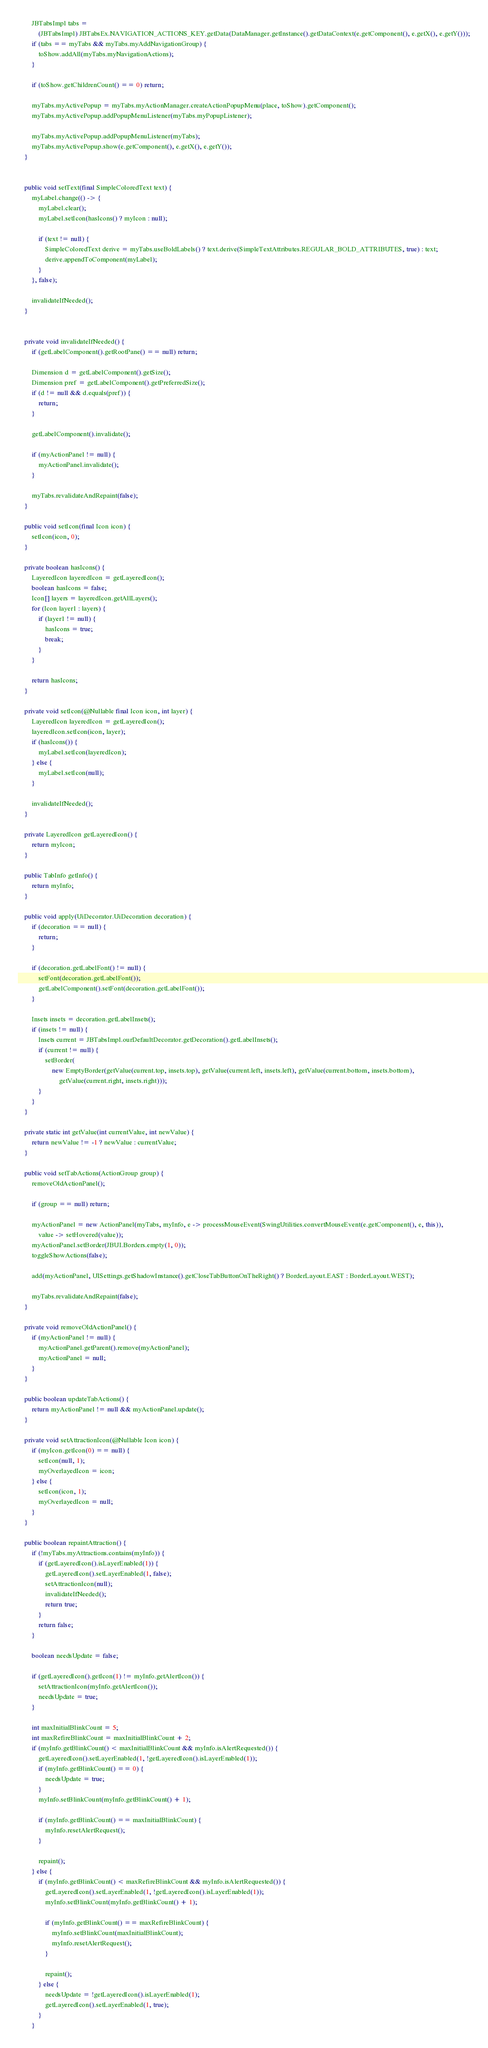Convert code to text. <code><loc_0><loc_0><loc_500><loc_500><_Java_>		JBTabsImpl tabs =
			(JBTabsImpl) JBTabsEx.NAVIGATION_ACTIONS_KEY.getData(DataManager.getInstance().getDataContext(e.getComponent(), e.getX(), e.getY()));
		if (tabs == myTabs && myTabs.myAddNavigationGroup) {
			toShow.addAll(myTabs.myNavigationActions);
		}

		if (toShow.getChildrenCount() == 0) return;

		myTabs.myActivePopup = myTabs.myActionManager.createActionPopupMenu(place, toShow).getComponent();
		myTabs.myActivePopup.addPopupMenuListener(myTabs.myPopupListener);

		myTabs.myActivePopup.addPopupMenuListener(myTabs);
		myTabs.myActivePopup.show(e.getComponent(), e.getX(), e.getY());
	}


	public void setText(final SimpleColoredText text) {
		myLabel.change(() -> {
			myLabel.clear();
			myLabel.setIcon(hasIcons() ? myIcon : null);

			if (text != null) {
				SimpleColoredText derive = myTabs.useBoldLabels() ? text.derive(SimpleTextAttributes.REGULAR_BOLD_ATTRIBUTES, true) : text;
				derive.appendToComponent(myLabel);
			}
		}, false);

		invalidateIfNeeded();
	}


	private void invalidateIfNeeded() {
		if (getLabelComponent().getRootPane() == null) return;

		Dimension d = getLabelComponent().getSize();
		Dimension pref = getLabelComponent().getPreferredSize();
		if (d != null && d.equals(pref)) {
			return;
		}

		getLabelComponent().invalidate();

		if (myActionPanel != null) {
			myActionPanel.invalidate();
		}

		myTabs.revalidateAndRepaint(false);
	}

	public void setIcon(final Icon icon) {
		setIcon(icon, 0);
	}

	private boolean hasIcons() {
		LayeredIcon layeredIcon = getLayeredIcon();
		boolean hasIcons = false;
		Icon[] layers = layeredIcon.getAllLayers();
		for (Icon layer1 : layers) {
			if (layer1 != null) {
				hasIcons = true;
				break;
			}
		}

		return hasIcons;
	}

	private void setIcon(@Nullable final Icon icon, int layer) {
		LayeredIcon layeredIcon = getLayeredIcon();
		layeredIcon.setIcon(icon, layer);
		if (hasIcons()) {
			myLabel.setIcon(layeredIcon);
		} else {
			myLabel.setIcon(null);
		}

		invalidateIfNeeded();
	}

	private LayeredIcon getLayeredIcon() {
		return myIcon;
	}

	public TabInfo getInfo() {
		return myInfo;
	}

	public void apply(UiDecorator.UiDecoration decoration) {
		if (decoration == null) {
			return;
		}

		if (decoration.getLabelFont() != null) {
			setFont(decoration.getLabelFont());
			getLabelComponent().setFont(decoration.getLabelFont());
		}

		Insets insets = decoration.getLabelInsets();
		if (insets != null) {
			Insets current = JBTabsImpl.ourDefaultDecorator.getDecoration().getLabelInsets();
			if (current != null) {
				setBorder(
					new EmptyBorder(getValue(current.top, insets.top), getValue(current.left, insets.left), getValue(current.bottom, insets.bottom),
						getValue(current.right, insets.right)));
			}
		}
	}

	private static int getValue(int currentValue, int newValue) {
		return newValue != -1 ? newValue : currentValue;
	}

	public void setTabActions(ActionGroup group) {
		removeOldActionPanel();

		if (group == null) return;

		myActionPanel = new ActionPanel(myTabs, myInfo, e -> processMouseEvent(SwingUtilities.convertMouseEvent(e.getComponent(), e, this)),
			value -> setHovered(value));
		myActionPanel.setBorder(JBUI.Borders.empty(1, 0));
		toggleShowActions(false);

		add(myActionPanel, UISettings.getShadowInstance().getCloseTabButtonOnTheRight() ? BorderLayout.EAST : BorderLayout.WEST);

		myTabs.revalidateAndRepaint(false);
	}

	private void removeOldActionPanel() {
		if (myActionPanel != null) {
			myActionPanel.getParent().remove(myActionPanel);
			myActionPanel = null;
		}
	}

	public boolean updateTabActions() {
		return myActionPanel != null && myActionPanel.update();
	}

	private void setAttractionIcon(@Nullable Icon icon) {
		if (myIcon.getIcon(0) == null) {
			setIcon(null, 1);
			myOverlayedIcon = icon;
		} else {
			setIcon(icon, 1);
			myOverlayedIcon = null;
		}
	}

	public boolean repaintAttraction() {
		if (!myTabs.myAttractions.contains(myInfo)) {
			if (getLayeredIcon().isLayerEnabled(1)) {
				getLayeredIcon().setLayerEnabled(1, false);
				setAttractionIcon(null);
				invalidateIfNeeded();
				return true;
			}
			return false;
		}

		boolean needsUpdate = false;

		if (getLayeredIcon().getIcon(1) != myInfo.getAlertIcon()) {
			setAttractionIcon(myInfo.getAlertIcon());
			needsUpdate = true;
		}

		int maxInitialBlinkCount = 5;
		int maxRefireBlinkCount = maxInitialBlinkCount + 2;
		if (myInfo.getBlinkCount() < maxInitialBlinkCount && myInfo.isAlertRequested()) {
			getLayeredIcon().setLayerEnabled(1, !getLayeredIcon().isLayerEnabled(1));
			if (myInfo.getBlinkCount() == 0) {
				needsUpdate = true;
			}
			myInfo.setBlinkCount(myInfo.getBlinkCount() + 1);

			if (myInfo.getBlinkCount() == maxInitialBlinkCount) {
				myInfo.resetAlertRequest();
			}

			repaint();
		} else {
			if (myInfo.getBlinkCount() < maxRefireBlinkCount && myInfo.isAlertRequested()) {
				getLayeredIcon().setLayerEnabled(1, !getLayeredIcon().isLayerEnabled(1));
				myInfo.setBlinkCount(myInfo.getBlinkCount() + 1);

				if (myInfo.getBlinkCount() == maxRefireBlinkCount) {
					myInfo.setBlinkCount(maxInitialBlinkCount);
					myInfo.resetAlertRequest();
				}

				repaint();
			} else {
				needsUpdate = !getLayeredIcon().isLayerEnabled(1);
				getLayeredIcon().setLayerEnabled(1, true);
			}
		}
</code> 